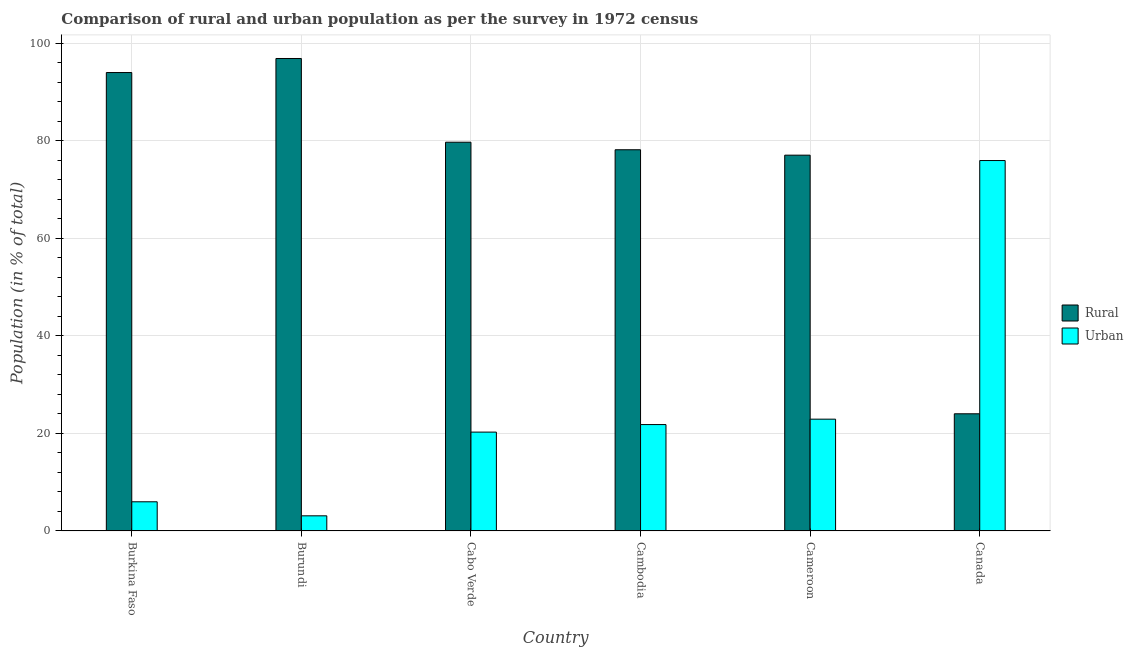How many different coloured bars are there?
Offer a very short reply. 2. How many bars are there on the 6th tick from the left?
Give a very brief answer. 2. How many bars are there on the 2nd tick from the right?
Keep it short and to the point. 2. What is the label of the 4th group of bars from the left?
Your response must be concise. Cambodia. What is the rural population in Burkina Faso?
Your answer should be compact. 94.02. Across all countries, what is the maximum rural population?
Ensure brevity in your answer.  96.9. Across all countries, what is the minimum urban population?
Ensure brevity in your answer.  3.1. In which country was the urban population maximum?
Provide a short and direct response. Canada. What is the total rural population in the graph?
Offer a terse response. 449.93. What is the difference between the rural population in Cabo Verde and that in Cameroon?
Give a very brief answer. 2.66. What is the difference between the rural population in Burkina Faso and the urban population in Canada?
Make the answer very short. 18.05. What is the average urban population per country?
Your response must be concise. 25.01. What is the difference between the urban population and rural population in Burundi?
Provide a succinct answer. -93.8. What is the ratio of the rural population in Cabo Verde to that in Cambodia?
Your response must be concise. 1.02. What is the difference between the highest and the second highest urban population?
Give a very brief answer. 53.04. What is the difference between the highest and the lowest rural population?
Your answer should be compact. 72.87. In how many countries, is the rural population greater than the average rural population taken over all countries?
Keep it short and to the point. 5. What does the 2nd bar from the left in Cabo Verde represents?
Your answer should be very brief. Urban. What does the 2nd bar from the right in Canada represents?
Your answer should be compact. Rural. Are all the bars in the graph horizontal?
Provide a short and direct response. No. How many countries are there in the graph?
Give a very brief answer. 6. Does the graph contain any zero values?
Offer a terse response. No. How many legend labels are there?
Offer a very short reply. 2. How are the legend labels stacked?
Offer a very short reply. Vertical. What is the title of the graph?
Your response must be concise. Comparison of rural and urban population as per the survey in 1972 census. Does "Exports of goods" appear as one of the legend labels in the graph?
Your answer should be compact. No. What is the label or title of the X-axis?
Offer a terse response. Country. What is the label or title of the Y-axis?
Offer a terse response. Population (in % of total). What is the Population (in % of total) of Rural in Burkina Faso?
Make the answer very short. 94.02. What is the Population (in % of total) of Urban in Burkina Faso?
Your response must be concise. 5.98. What is the Population (in % of total) of Rural in Burundi?
Ensure brevity in your answer.  96.9. What is the Population (in % of total) in Urban in Burundi?
Ensure brevity in your answer.  3.1. What is the Population (in % of total) in Rural in Cabo Verde?
Offer a terse response. 79.73. What is the Population (in % of total) of Urban in Cabo Verde?
Make the answer very short. 20.27. What is the Population (in % of total) in Rural in Cambodia?
Give a very brief answer. 78.18. What is the Population (in % of total) of Urban in Cambodia?
Provide a succinct answer. 21.82. What is the Population (in % of total) of Rural in Cameroon?
Keep it short and to the point. 77.07. What is the Population (in % of total) of Urban in Cameroon?
Provide a short and direct response. 22.93. What is the Population (in % of total) in Rural in Canada?
Offer a terse response. 24.03. What is the Population (in % of total) of Urban in Canada?
Provide a short and direct response. 75.97. Across all countries, what is the maximum Population (in % of total) of Rural?
Provide a short and direct response. 96.9. Across all countries, what is the maximum Population (in % of total) in Urban?
Keep it short and to the point. 75.97. Across all countries, what is the minimum Population (in % of total) of Rural?
Keep it short and to the point. 24.03. Across all countries, what is the minimum Population (in % of total) of Urban?
Keep it short and to the point. 3.1. What is the total Population (in % of total) in Rural in the graph?
Offer a very short reply. 449.93. What is the total Population (in % of total) in Urban in the graph?
Give a very brief answer. 150.07. What is the difference between the Population (in % of total) in Rural in Burkina Faso and that in Burundi?
Provide a succinct answer. -2.88. What is the difference between the Population (in % of total) in Urban in Burkina Faso and that in Burundi?
Make the answer very short. 2.88. What is the difference between the Population (in % of total) in Rural in Burkina Faso and that in Cabo Verde?
Your answer should be very brief. 14.29. What is the difference between the Population (in % of total) of Urban in Burkina Faso and that in Cabo Verde?
Provide a succinct answer. -14.29. What is the difference between the Population (in % of total) of Rural in Burkina Faso and that in Cambodia?
Your answer should be compact. 15.84. What is the difference between the Population (in % of total) of Urban in Burkina Faso and that in Cambodia?
Your answer should be compact. -15.84. What is the difference between the Population (in % of total) in Rural in Burkina Faso and that in Cameroon?
Your response must be concise. 16.95. What is the difference between the Population (in % of total) of Urban in Burkina Faso and that in Cameroon?
Your answer should be compact. -16.95. What is the difference between the Population (in % of total) of Rural in Burkina Faso and that in Canada?
Give a very brief answer. 69.99. What is the difference between the Population (in % of total) in Urban in Burkina Faso and that in Canada?
Provide a short and direct response. -69.99. What is the difference between the Population (in % of total) in Rural in Burundi and that in Cabo Verde?
Offer a very short reply. 17.17. What is the difference between the Population (in % of total) of Urban in Burundi and that in Cabo Verde?
Ensure brevity in your answer.  -17.17. What is the difference between the Population (in % of total) in Rural in Burundi and that in Cambodia?
Your answer should be compact. 18.72. What is the difference between the Population (in % of total) of Urban in Burundi and that in Cambodia?
Keep it short and to the point. -18.72. What is the difference between the Population (in % of total) of Rural in Burundi and that in Cameroon?
Ensure brevity in your answer.  19.83. What is the difference between the Population (in % of total) in Urban in Burundi and that in Cameroon?
Your answer should be compact. -19.83. What is the difference between the Population (in % of total) in Rural in Burundi and that in Canada?
Provide a succinct answer. 72.87. What is the difference between the Population (in % of total) in Urban in Burundi and that in Canada?
Provide a short and direct response. -72.87. What is the difference between the Population (in % of total) of Rural in Cabo Verde and that in Cambodia?
Keep it short and to the point. 1.55. What is the difference between the Population (in % of total) in Urban in Cabo Verde and that in Cambodia?
Give a very brief answer. -1.55. What is the difference between the Population (in % of total) in Rural in Cabo Verde and that in Cameroon?
Make the answer very short. 2.65. What is the difference between the Population (in % of total) of Urban in Cabo Verde and that in Cameroon?
Your response must be concise. -2.65. What is the difference between the Population (in % of total) in Rural in Cabo Verde and that in Canada?
Give a very brief answer. 55.7. What is the difference between the Population (in % of total) in Urban in Cabo Verde and that in Canada?
Your answer should be compact. -55.7. What is the difference between the Population (in % of total) in Rural in Cambodia and that in Cameroon?
Make the answer very short. 1.11. What is the difference between the Population (in % of total) in Urban in Cambodia and that in Cameroon?
Give a very brief answer. -1.11. What is the difference between the Population (in % of total) of Rural in Cambodia and that in Canada?
Provide a short and direct response. 54.15. What is the difference between the Population (in % of total) in Urban in Cambodia and that in Canada?
Give a very brief answer. -54.15. What is the difference between the Population (in % of total) in Rural in Cameroon and that in Canada?
Your answer should be compact. 53.04. What is the difference between the Population (in % of total) in Urban in Cameroon and that in Canada?
Provide a short and direct response. -53.04. What is the difference between the Population (in % of total) in Rural in Burkina Faso and the Population (in % of total) in Urban in Burundi?
Your answer should be compact. 90.92. What is the difference between the Population (in % of total) of Rural in Burkina Faso and the Population (in % of total) of Urban in Cabo Verde?
Offer a very short reply. 73.75. What is the difference between the Population (in % of total) of Rural in Burkina Faso and the Population (in % of total) of Urban in Cambodia?
Provide a short and direct response. 72.2. What is the difference between the Population (in % of total) of Rural in Burkina Faso and the Population (in % of total) of Urban in Cameroon?
Offer a terse response. 71.09. What is the difference between the Population (in % of total) of Rural in Burkina Faso and the Population (in % of total) of Urban in Canada?
Offer a very short reply. 18.05. What is the difference between the Population (in % of total) in Rural in Burundi and the Population (in % of total) in Urban in Cabo Verde?
Offer a terse response. 76.63. What is the difference between the Population (in % of total) in Rural in Burundi and the Population (in % of total) in Urban in Cambodia?
Your response must be concise. 75.08. What is the difference between the Population (in % of total) in Rural in Burundi and the Population (in % of total) in Urban in Cameroon?
Offer a terse response. 73.97. What is the difference between the Population (in % of total) of Rural in Burundi and the Population (in % of total) of Urban in Canada?
Offer a terse response. 20.93. What is the difference between the Population (in % of total) in Rural in Cabo Verde and the Population (in % of total) in Urban in Cambodia?
Your answer should be very brief. 57.91. What is the difference between the Population (in % of total) of Rural in Cabo Verde and the Population (in % of total) of Urban in Cameroon?
Your answer should be compact. 56.8. What is the difference between the Population (in % of total) of Rural in Cabo Verde and the Population (in % of total) of Urban in Canada?
Offer a terse response. 3.76. What is the difference between the Population (in % of total) in Rural in Cambodia and the Population (in % of total) in Urban in Cameroon?
Your answer should be very brief. 55.26. What is the difference between the Population (in % of total) of Rural in Cambodia and the Population (in % of total) of Urban in Canada?
Ensure brevity in your answer.  2.21. What is the difference between the Population (in % of total) of Rural in Cameroon and the Population (in % of total) of Urban in Canada?
Make the answer very short. 1.1. What is the average Population (in % of total) of Rural per country?
Offer a terse response. 74.99. What is the average Population (in % of total) of Urban per country?
Keep it short and to the point. 25.01. What is the difference between the Population (in % of total) in Rural and Population (in % of total) in Urban in Burkina Faso?
Your response must be concise. 88.04. What is the difference between the Population (in % of total) in Rural and Population (in % of total) in Urban in Burundi?
Provide a short and direct response. 93.8. What is the difference between the Population (in % of total) of Rural and Population (in % of total) of Urban in Cabo Verde?
Provide a short and direct response. 59.46. What is the difference between the Population (in % of total) of Rural and Population (in % of total) of Urban in Cambodia?
Make the answer very short. 56.36. What is the difference between the Population (in % of total) in Rural and Population (in % of total) in Urban in Cameroon?
Ensure brevity in your answer.  54.15. What is the difference between the Population (in % of total) of Rural and Population (in % of total) of Urban in Canada?
Give a very brief answer. -51.94. What is the ratio of the Population (in % of total) of Rural in Burkina Faso to that in Burundi?
Provide a short and direct response. 0.97. What is the ratio of the Population (in % of total) of Urban in Burkina Faso to that in Burundi?
Offer a terse response. 1.93. What is the ratio of the Population (in % of total) of Rural in Burkina Faso to that in Cabo Verde?
Give a very brief answer. 1.18. What is the ratio of the Population (in % of total) in Urban in Burkina Faso to that in Cabo Verde?
Ensure brevity in your answer.  0.29. What is the ratio of the Population (in % of total) of Rural in Burkina Faso to that in Cambodia?
Your answer should be very brief. 1.2. What is the ratio of the Population (in % of total) in Urban in Burkina Faso to that in Cambodia?
Your response must be concise. 0.27. What is the ratio of the Population (in % of total) of Rural in Burkina Faso to that in Cameroon?
Ensure brevity in your answer.  1.22. What is the ratio of the Population (in % of total) of Urban in Burkina Faso to that in Cameroon?
Your answer should be very brief. 0.26. What is the ratio of the Population (in % of total) of Rural in Burkina Faso to that in Canada?
Provide a short and direct response. 3.91. What is the ratio of the Population (in % of total) of Urban in Burkina Faso to that in Canada?
Your response must be concise. 0.08. What is the ratio of the Population (in % of total) in Rural in Burundi to that in Cabo Verde?
Your answer should be compact. 1.22. What is the ratio of the Population (in % of total) in Urban in Burundi to that in Cabo Verde?
Offer a terse response. 0.15. What is the ratio of the Population (in % of total) of Rural in Burundi to that in Cambodia?
Provide a short and direct response. 1.24. What is the ratio of the Population (in % of total) of Urban in Burundi to that in Cambodia?
Your answer should be very brief. 0.14. What is the ratio of the Population (in % of total) of Rural in Burundi to that in Cameroon?
Ensure brevity in your answer.  1.26. What is the ratio of the Population (in % of total) of Urban in Burundi to that in Cameroon?
Provide a short and direct response. 0.14. What is the ratio of the Population (in % of total) of Rural in Burundi to that in Canada?
Make the answer very short. 4.03. What is the ratio of the Population (in % of total) of Urban in Burundi to that in Canada?
Your answer should be very brief. 0.04. What is the ratio of the Population (in % of total) of Rural in Cabo Verde to that in Cambodia?
Provide a succinct answer. 1.02. What is the ratio of the Population (in % of total) of Urban in Cabo Verde to that in Cambodia?
Offer a terse response. 0.93. What is the ratio of the Population (in % of total) of Rural in Cabo Verde to that in Cameroon?
Your answer should be very brief. 1.03. What is the ratio of the Population (in % of total) of Urban in Cabo Verde to that in Cameroon?
Give a very brief answer. 0.88. What is the ratio of the Population (in % of total) of Rural in Cabo Verde to that in Canada?
Offer a very short reply. 3.32. What is the ratio of the Population (in % of total) in Urban in Cabo Verde to that in Canada?
Provide a short and direct response. 0.27. What is the ratio of the Population (in % of total) in Rural in Cambodia to that in Cameroon?
Make the answer very short. 1.01. What is the ratio of the Population (in % of total) in Urban in Cambodia to that in Cameroon?
Provide a short and direct response. 0.95. What is the ratio of the Population (in % of total) of Rural in Cambodia to that in Canada?
Provide a succinct answer. 3.25. What is the ratio of the Population (in % of total) of Urban in Cambodia to that in Canada?
Make the answer very short. 0.29. What is the ratio of the Population (in % of total) in Rural in Cameroon to that in Canada?
Your answer should be compact. 3.21. What is the ratio of the Population (in % of total) of Urban in Cameroon to that in Canada?
Ensure brevity in your answer.  0.3. What is the difference between the highest and the second highest Population (in % of total) of Rural?
Ensure brevity in your answer.  2.88. What is the difference between the highest and the second highest Population (in % of total) in Urban?
Your answer should be compact. 53.04. What is the difference between the highest and the lowest Population (in % of total) of Rural?
Keep it short and to the point. 72.87. What is the difference between the highest and the lowest Population (in % of total) of Urban?
Offer a terse response. 72.87. 